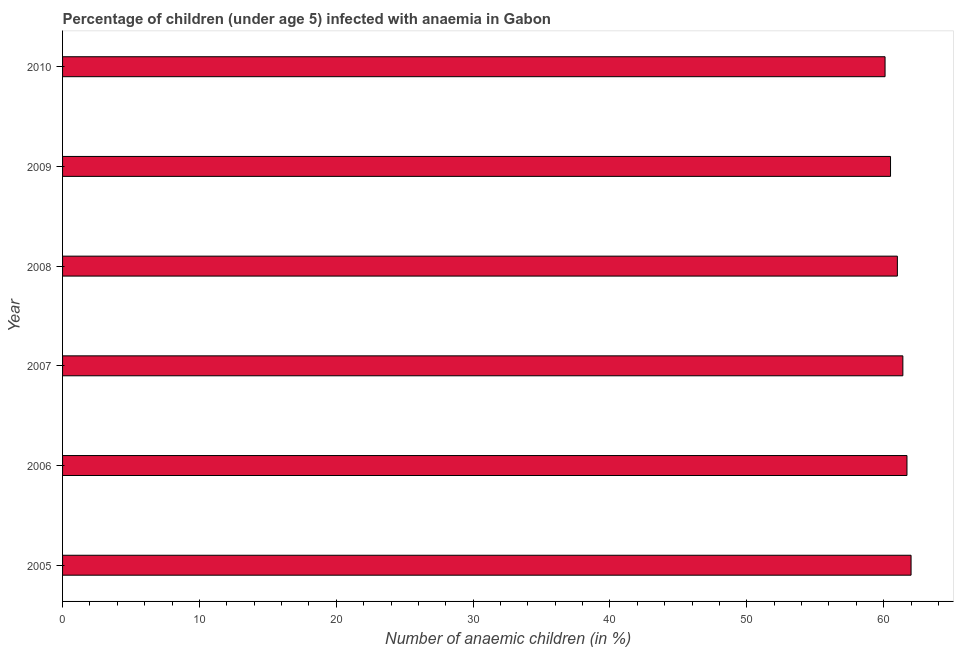Does the graph contain grids?
Provide a short and direct response. No. What is the title of the graph?
Offer a terse response. Percentage of children (under age 5) infected with anaemia in Gabon. What is the label or title of the X-axis?
Your answer should be compact. Number of anaemic children (in %). What is the label or title of the Y-axis?
Give a very brief answer. Year. What is the number of anaemic children in 2007?
Make the answer very short. 61.4. Across all years, what is the minimum number of anaemic children?
Provide a succinct answer. 60.1. In which year was the number of anaemic children maximum?
Your answer should be compact. 2005. What is the sum of the number of anaemic children?
Provide a short and direct response. 366.7. What is the difference between the number of anaemic children in 2006 and 2010?
Keep it short and to the point. 1.6. What is the average number of anaemic children per year?
Make the answer very short. 61.12. What is the median number of anaemic children?
Make the answer very short. 61.2. What is the ratio of the number of anaemic children in 2005 to that in 2010?
Give a very brief answer. 1.03. Is the number of anaemic children in 2005 less than that in 2009?
Your response must be concise. No. Is the difference between the number of anaemic children in 2006 and 2010 greater than the difference between any two years?
Your answer should be compact. No. What is the difference between the highest and the second highest number of anaemic children?
Offer a terse response. 0.3. Is the sum of the number of anaemic children in 2007 and 2008 greater than the maximum number of anaemic children across all years?
Your response must be concise. Yes. How many bars are there?
Offer a terse response. 6. Are all the bars in the graph horizontal?
Provide a succinct answer. Yes. How many years are there in the graph?
Your answer should be compact. 6. What is the Number of anaemic children (in %) in 2005?
Ensure brevity in your answer.  62. What is the Number of anaemic children (in %) of 2006?
Keep it short and to the point. 61.7. What is the Number of anaemic children (in %) in 2007?
Keep it short and to the point. 61.4. What is the Number of anaemic children (in %) in 2009?
Offer a very short reply. 60.5. What is the Number of anaemic children (in %) in 2010?
Provide a succinct answer. 60.1. What is the difference between the Number of anaemic children (in %) in 2005 and 2009?
Your response must be concise. 1.5. What is the difference between the Number of anaemic children (in %) in 2005 and 2010?
Offer a terse response. 1.9. What is the difference between the Number of anaemic children (in %) in 2006 and 2007?
Provide a short and direct response. 0.3. What is the difference between the Number of anaemic children (in %) in 2006 and 2010?
Your answer should be compact. 1.6. What is the difference between the Number of anaemic children (in %) in 2007 and 2008?
Ensure brevity in your answer.  0.4. What is the difference between the Number of anaemic children (in %) in 2007 and 2009?
Offer a very short reply. 0.9. What is the difference between the Number of anaemic children (in %) in 2007 and 2010?
Your answer should be compact. 1.3. What is the difference between the Number of anaemic children (in %) in 2008 and 2010?
Provide a succinct answer. 0.9. What is the difference between the Number of anaemic children (in %) in 2009 and 2010?
Offer a very short reply. 0.4. What is the ratio of the Number of anaemic children (in %) in 2005 to that in 2006?
Offer a very short reply. 1. What is the ratio of the Number of anaemic children (in %) in 2005 to that in 2007?
Your answer should be very brief. 1.01. What is the ratio of the Number of anaemic children (in %) in 2005 to that in 2008?
Offer a very short reply. 1.02. What is the ratio of the Number of anaemic children (in %) in 2005 to that in 2009?
Give a very brief answer. 1.02. What is the ratio of the Number of anaemic children (in %) in 2005 to that in 2010?
Your response must be concise. 1.03. What is the ratio of the Number of anaemic children (in %) in 2006 to that in 2008?
Offer a terse response. 1.01. What is the ratio of the Number of anaemic children (in %) in 2006 to that in 2009?
Your answer should be compact. 1.02. What is the ratio of the Number of anaemic children (in %) in 2007 to that in 2008?
Offer a terse response. 1.01. What is the ratio of the Number of anaemic children (in %) in 2007 to that in 2010?
Your answer should be very brief. 1.02. What is the ratio of the Number of anaemic children (in %) in 2008 to that in 2009?
Your answer should be compact. 1.01. What is the ratio of the Number of anaemic children (in %) in 2009 to that in 2010?
Make the answer very short. 1.01. 